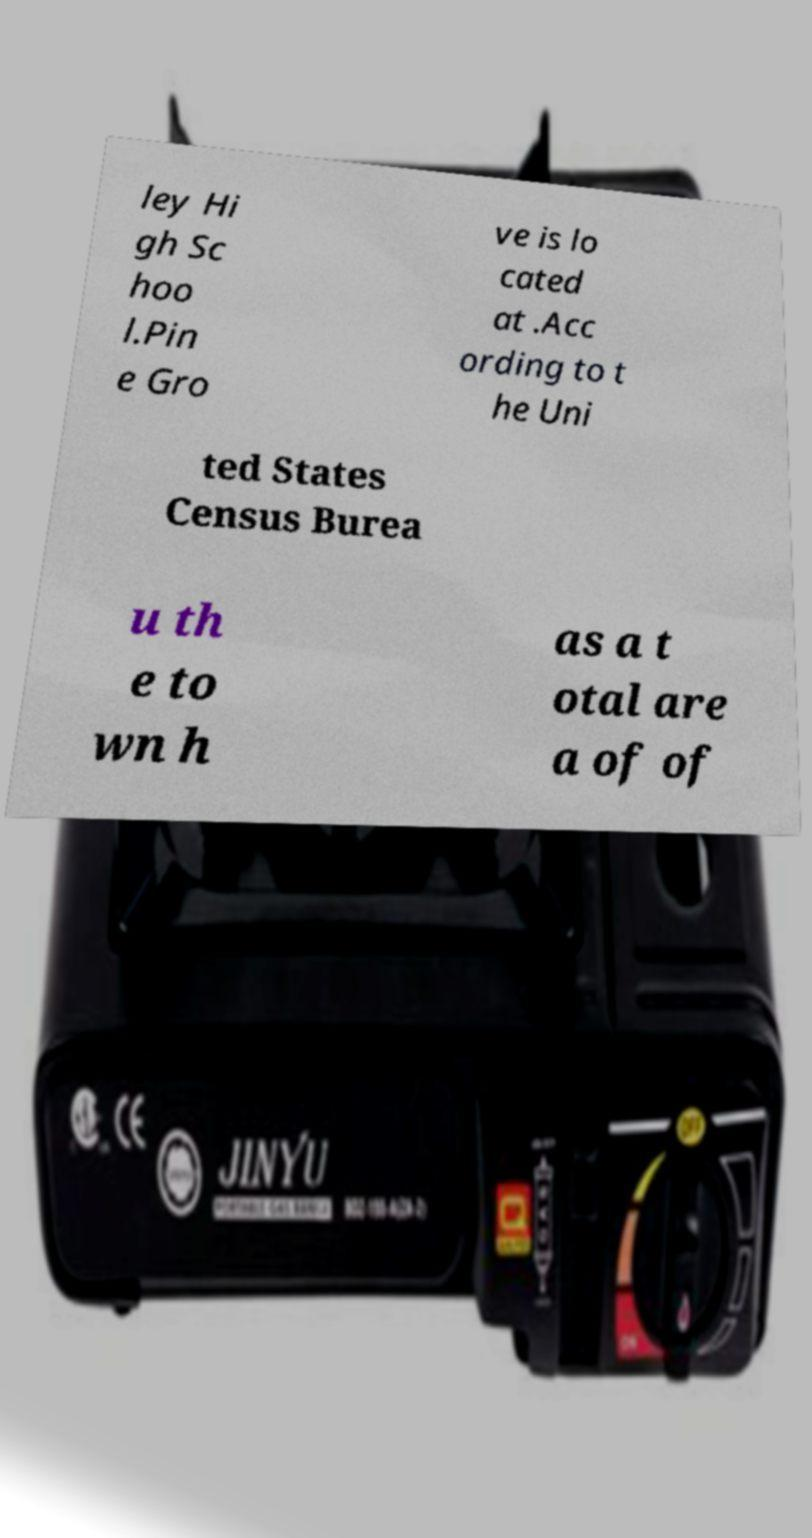Please identify and transcribe the text found in this image. ley Hi gh Sc hoo l.Pin e Gro ve is lo cated at .Acc ording to t he Uni ted States Census Burea u th e to wn h as a t otal are a of of 